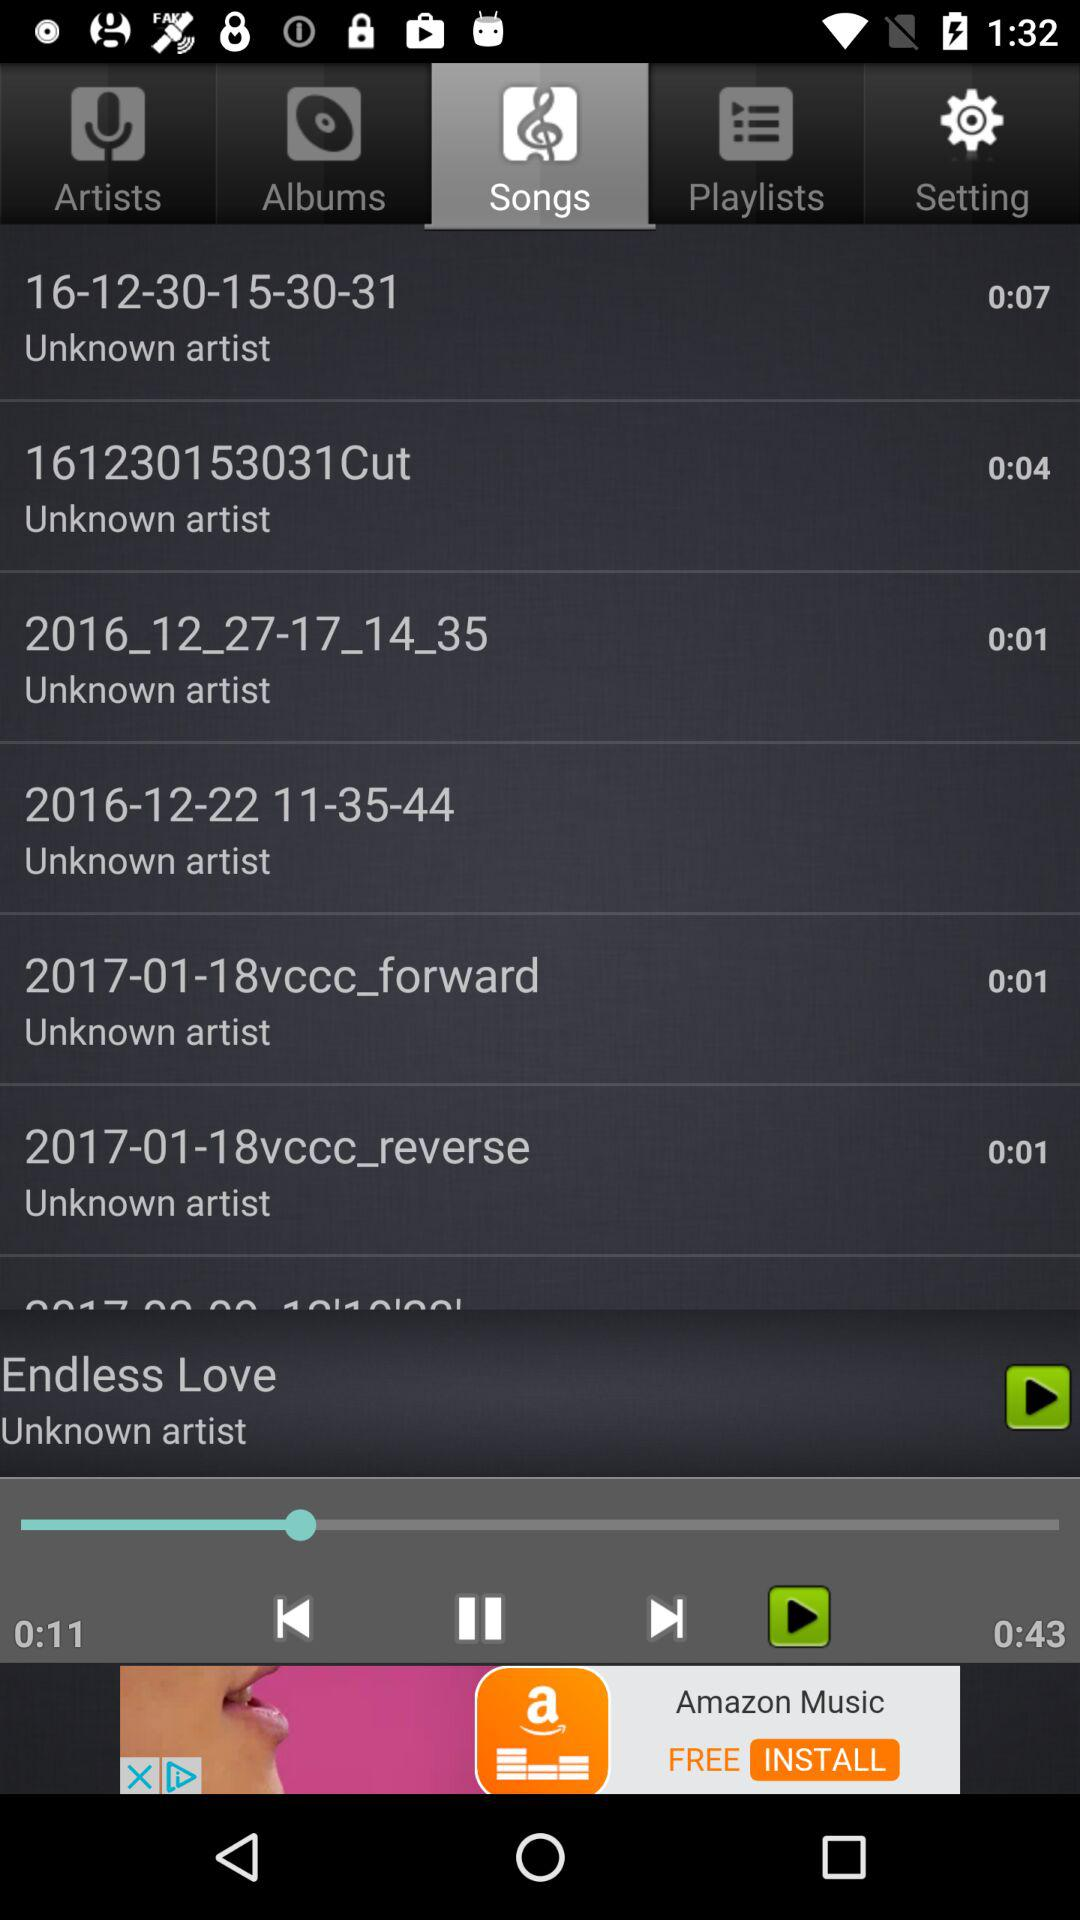What's the length of the currently playing song? The length of the currently playing song is 43 seconds. 